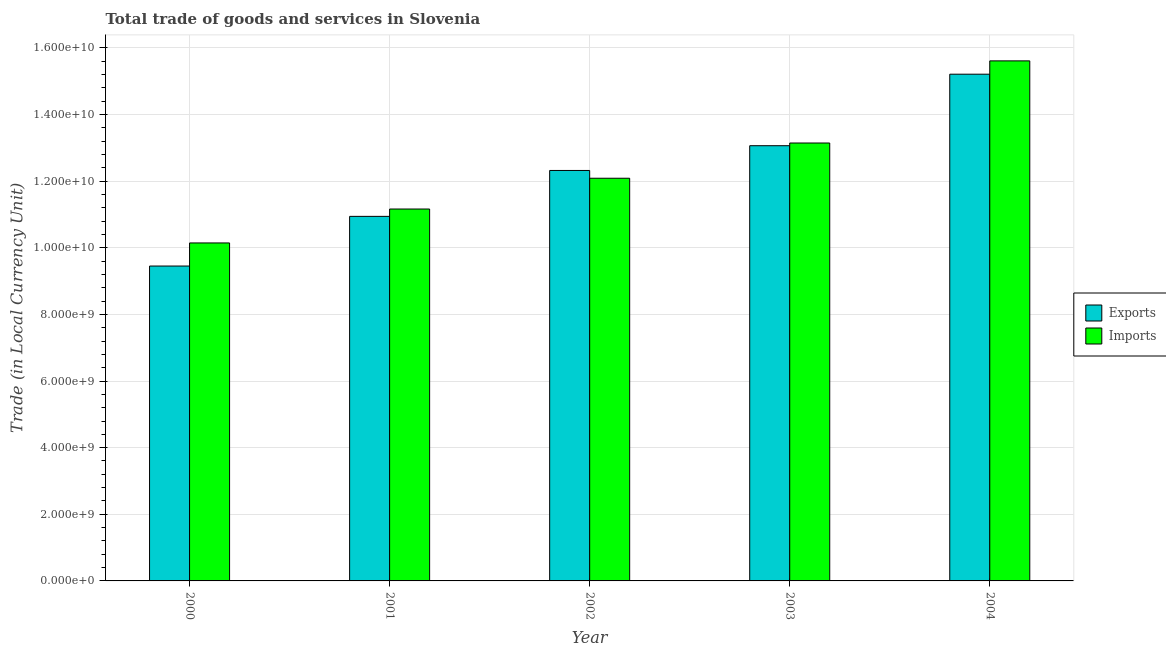How many different coloured bars are there?
Ensure brevity in your answer.  2. How many groups of bars are there?
Make the answer very short. 5. Are the number of bars per tick equal to the number of legend labels?
Your response must be concise. Yes. Are the number of bars on each tick of the X-axis equal?
Offer a very short reply. Yes. How many bars are there on the 4th tick from the right?
Offer a terse response. 2. What is the label of the 3rd group of bars from the left?
Provide a short and direct response. 2002. What is the imports of goods and services in 2001?
Keep it short and to the point. 1.12e+1. Across all years, what is the maximum imports of goods and services?
Your response must be concise. 1.56e+1. Across all years, what is the minimum export of goods and services?
Offer a very short reply. 9.45e+09. What is the total imports of goods and services in the graph?
Give a very brief answer. 6.22e+1. What is the difference between the export of goods and services in 2001 and that in 2002?
Your answer should be compact. -1.38e+09. What is the difference between the imports of goods and services in 2001 and the export of goods and services in 2004?
Give a very brief answer. -4.45e+09. What is the average imports of goods and services per year?
Your response must be concise. 1.24e+1. What is the ratio of the imports of goods and services in 2002 to that in 2003?
Your answer should be very brief. 0.92. Is the difference between the imports of goods and services in 2002 and 2003 greater than the difference between the export of goods and services in 2002 and 2003?
Give a very brief answer. No. What is the difference between the highest and the second highest export of goods and services?
Make the answer very short. 2.15e+09. What is the difference between the highest and the lowest imports of goods and services?
Offer a terse response. 5.47e+09. In how many years, is the imports of goods and services greater than the average imports of goods and services taken over all years?
Offer a very short reply. 2. Is the sum of the imports of goods and services in 2001 and 2002 greater than the maximum export of goods and services across all years?
Your answer should be compact. Yes. What does the 2nd bar from the left in 2002 represents?
Offer a very short reply. Imports. What does the 1st bar from the right in 2003 represents?
Offer a very short reply. Imports. How many bars are there?
Your answer should be compact. 10. Are all the bars in the graph horizontal?
Your answer should be very brief. No. What is the difference between two consecutive major ticks on the Y-axis?
Your answer should be very brief. 2.00e+09. Where does the legend appear in the graph?
Keep it short and to the point. Center right. How many legend labels are there?
Ensure brevity in your answer.  2. What is the title of the graph?
Give a very brief answer. Total trade of goods and services in Slovenia. Does "Stunting" appear as one of the legend labels in the graph?
Provide a succinct answer. No. What is the label or title of the X-axis?
Provide a short and direct response. Year. What is the label or title of the Y-axis?
Your answer should be very brief. Trade (in Local Currency Unit). What is the Trade (in Local Currency Unit) of Exports in 2000?
Make the answer very short. 9.45e+09. What is the Trade (in Local Currency Unit) in Imports in 2000?
Your response must be concise. 1.01e+1. What is the Trade (in Local Currency Unit) of Exports in 2001?
Offer a very short reply. 1.09e+1. What is the Trade (in Local Currency Unit) in Imports in 2001?
Offer a terse response. 1.12e+1. What is the Trade (in Local Currency Unit) in Exports in 2002?
Keep it short and to the point. 1.23e+1. What is the Trade (in Local Currency Unit) of Imports in 2002?
Your answer should be very brief. 1.21e+1. What is the Trade (in Local Currency Unit) of Exports in 2003?
Ensure brevity in your answer.  1.31e+1. What is the Trade (in Local Currency Unit) of Imports in 2003?
Your response must be concise. 1.31e+1. What is the Trade (in Local Currency Unit) of Exports in 2004?
Keep it short and to the point. 1.52e+1. What is the Trade (in Local Currency Unit) in Imports in 2004?
Provide a succinct answer. 1.56e+1. Across all years, what is the maximum Trade (in Local Currency Unit) in Exports?
Your answer should be very brief. 1.52e+1. Across all years, what is the maximum Trade (in Local Currency Unit) in Imports?
Provide a succinct answer. 1.56e+1. Across all years, what is the minimum Trade (in Local Currency Unit) in Exports?
Your answer should be very brief. 9.45e+09. Across all years, what is the minimum Trade (in Local Currency Unit) of Imports?
Your answer should be compact. 1.01e+1. What is the total Trade (in Local Currency Unit) of Exports in the graph?
Your answer should be very brief. 6.10e+1. What is the total Trade (in Local Currency Unit) of Imports in the graph?
Ensure brevity in your answer.  6.22e+1. What is the difference between the Trade (in Local Currency Unit) of Exports in 2000 and that in 2001?
Your response must be concise. -1.49e+09. What is the difference between the Trade (in Local Currency Unit) in Imports in 2000 and that in 2001?
Keep it short and to the point. -1.02e+09. What is the difference between the Trade (in Local Currency Unit) in Exports in 2000 and that in 2002?
Your response must be concise. -2.87e+09. What is the difference between the Trade (in Local Currency Unit) of Imports in 2000 and that in 2002?
Ensure brevity in your answer.  -1.94e+09. What is the difference between the Trade (in Local Currency Unit) in Exports in 2000 and that in 2003?
Make the answer very short. -3.61e+09. What is the difference between the Trade (in Local Currency Unit) in Imports in 2000 and that in 2003?
Your response must be concise. -3.00e+09. What is the difference between the Trade (in Local Currency Unit) of Exports in 2000 and that in 2004?
Your answer should be compact. -5.76e+09. What is the difference between the Trade (in Local Currency Unit) in Imports in 2000 and that in 2004?
Provide a succinct answer. -5.47e+09. What is the difference between the Trade (in Local Currency Unit) of Exports in 2001 and that in 2002?
Provide a short and direct response. -1.38e+09. What is the difference between the Trade (in Local Currency Unit) of Imports in 2001 and that in 2002?
Your answer should be compact. -9.24e+08. What is the difference between the Trade (in Local Currency Unit) of Exports in 2001 and that in 2003?
Offer a terse response. -2.12e+09. What is the difference between the Trade (in Local Currency Unit) of Imports in 2001 and that in 2003?
Your response must be concise. -1.98e+09. What is the difference between the Trade (in Local Currency Unit) of Exports in 2001 and that in 2004?
Offer a terse response. -4.27e+09. What is the difference between the Trade (in Local Currency Unit) of Imports in 2001 and that in 2004?
Ensure brevity in your answer.  -4.45e+09. What is the difference between the Trade (in Local Currency Unit) of Exports in 2002 and that in 2003?
Provide a short and direct response. -7.43e+08. What is the difference between the Trade (in Local Currency Unit) of Imports in 2002 and that in 2003?
Your answer should be very brief. -1.06e+09. What is the difference between the Trade (in Local Currency Unit) of Exports in 2002 and that in 2004?
Offer a very short reply. -2.89e+09. What is the difference between the Trade (in Local Currency Unit) of Imports in 2002 and that in 2004?
Give a very brief answer. -3.52e+09. What is the difference between the Trade (in Local Currency Unit) of Exports in 2003 and that in 2004?
Give a very brief answer. -2.15e+09. What is the difference between the Trade (in Local Currency Unit) in Imports in 2003 and that in 2004?
Your answer should be very brief. -2.47e+09. What is the difference between the Trade (in Local Currency Unit) of Exports in 2000 and the Trade (in Local Currency Unit) of Imports in 2001?
Keep it short and to the point. -1.71e+09. What is the difference between the Trade (in Local Currency Unit) in Exports in 2000 and the Trade (in Local Currency Unit) in Imports in 2002?
Your response must be concise. -2.64e+09. What is the difference between the Trade (in Local Currency Unit) of Exports in 2000 and the Trade (in Local Currency Unit) of Imports in 2003?
Give a very brief answer. -3.69e+09. What is the difference between the Trade (in Local Currency Unit) of Exports in 2000 and the Trade (in Local Currency Unit) of Imports in 2004?
Your answer should be very brief. -6.16e+09. What is the difference between the Trade (in Local Currency Unit) in Exports in 2001 and the Trade (in Local Currency Unit) in Imports in 2002?
Make the answer very short. -1.14e+09. What is the difference between the Trade (in Local Currency Unit) of Exports in 2001 and the Trade (in Local Currency Unit) of Imports in 2003?
Your response must be concise. -2.20e+09. What is the difference between the Trade (in Local Currency Unit) of Exports in 2001 and the Trade (in Local Currency Unit) of Imports in 2004?
Offer a terse response. -4.67e+09. What is the difference between the Trade (in Local Currency Unit) in Exports in 2002 and the Trade (in Local Currency Unit) in Imports in 2003?
Keep it short and to the point. -8.24e+08. What is the difference between the Trade (in Local Currency Unit) of Exports in 2002 and the Trade (in Local Currency Unit) of Imports in 2004?
Give a very brief answer. -3.29e+09. What is the difference between the Trade (in Local Currency Unit) of Exports in 2003 and the Trade (in Local Currency Unit) of Imports in 2004?
Ensure brevity in your answer.  -2.55e+09. What is the average Trade (in Local Currency Unit) in Exports per year?
Your answer should be very brief. 1.22e+1. What is the average Trade (in Local Currency Unit) in Imports per year?
Your response must be concise. 1.24e+1. In the year 2000, what is the difference between the Trade (in Local Currency Unit) in Exports and Trade (in Local Currency Unit) in Imports?
Make the answer very short. -6.93e+08. In the year 2001, what is the difference between the Trade (in Local Currency Unit) of Exports and Trade (in Local Currency Unit) of Imports?
Offer a very short reply. -2.20e+08. In the year 2002, what is the difference between the Trade (in Local Currency Unit) in Exports and Trade (in Local Currency Unit) in Imports?
Provide a succinct answer. 2.33e+08. In the year 2003, what is the difference between the Trade (in Local Currency Unit) in Exports and Trade (in Local Currency Unit) in Imports?
Provide a succinct answer. -8.13e+07. In the year 2004, what is the difference between the Trade (in Local Currency Unit) of Exports and Trade (in Local Currency Unit) of Imports?
Ensure brevity in your answer.  -4.00e+08. What is the ratio of the Trade (in Local Currency Unit) of Exports in 2000 to that in 2001?
Your answer should be compact. 0.86. What is the ratio of the Trade (in Local Currency Unit) of Imports in 2000 to that in 2001?
Keep it short and to the point. 0.91. What is the ratio of the Trade (in Local Currency Unit) in Exports in 2000 to that in 2002?
Your answer should be compact. 0.77. What is the ratio of the Trade (in Local Currency Unit) of Imports in 2000 to that in 2002?
Provide a short and direct response. 0.84. What is the ratio of the Trade (in Local Currency Unit) of Exports in 2000 to that in 2003?
Your answer should be very brief. 0.72. What is the ratio of the Trade (in Local Currency Unit) in Imports in 2000 to that in 2003?
Offer a terse response. 0.77. What is the ratio of the Trade (in Local Currency Unit) in Exports in 2000 to that in 2004?
Provide a succinct answer. 0.62. What is the ratio of the Trade (in Local Currency Unit) in Imports in 2000 to that in 2004?
Provide a short and direct response. 0.65. What is the ratio of the Trade (in Local Currency Unit) of Exports in 2001 to that in 2002?
Give a very brief answer. 0.89. What is the ratio of the Trade (in Local Currency Unit) of Imports in 2001 to that in 2002?
Offer a very short reply. 0.92. What is the ratio of the Trade (in Local Currency Unit) of Exports in 2001 to that in 2003?
Offer a very short reply. 0.84. What is the ratio of the Trade (in Local Currency Unit) of Imports in 2001 to that in 2003?
Offer a terse response. 0.85. What is the ratio of the Trade (in Local Currency Unit) in Exports in 2001 to that in 2004?
Your answer should be very brief. 0.72. What is the ratio of the Trade (in Local Currency Unit) in Imports in 2001 to that in 2004?
Offer a very short reply. 0.72. What is the ratio of the Trade (in Local Currency Unit) of Exports in 2002 to that in 2003?
Your answer should be very brief. 0.94. What is the ratio of the Trade (in Local Currency Unit) in Imports in 2002 to that in 2003?
Provide a short and direct response. 0.92. What is the ratio of the Trade (in Local Currency Unit) of Exports in 2002 to that in 2004?
Your answer should be very brief. 0.81. What is the ratio of the Trade (in Local Currency Unit) in Imports in 2002 to that in 2004?
Provide a succinct answer. 0.77. What is the ratio of the Trade (in Local Currency Unit) of Exports in 2003 to that in 2004?
Keep it short and to the point. 0.86. What is the ratio of the Trade (in Local Currency Unit) of Imports in 2003 to that in 2004?
Ensure brevity in your answer.  0.84. What is the difference between the highest and the second highest Trade (in Local Currency Unit) of Exports?
Give a very brief answer. 2.15e+09. What is the difference between the highest and the second highest Trade (in Local Currency Unit) of Imports?
Make the answer very short. 2.47e+09. What is the difference between the highest and the lowest Trade (in Local Currency Unit) in Exports?
Keep it short and to the point. 5.76e+09. What is the difference between the highest and the lowest Trade (in Local Currency Unit) of Imports?
Provide a short and direct response. 5.47e+09. 